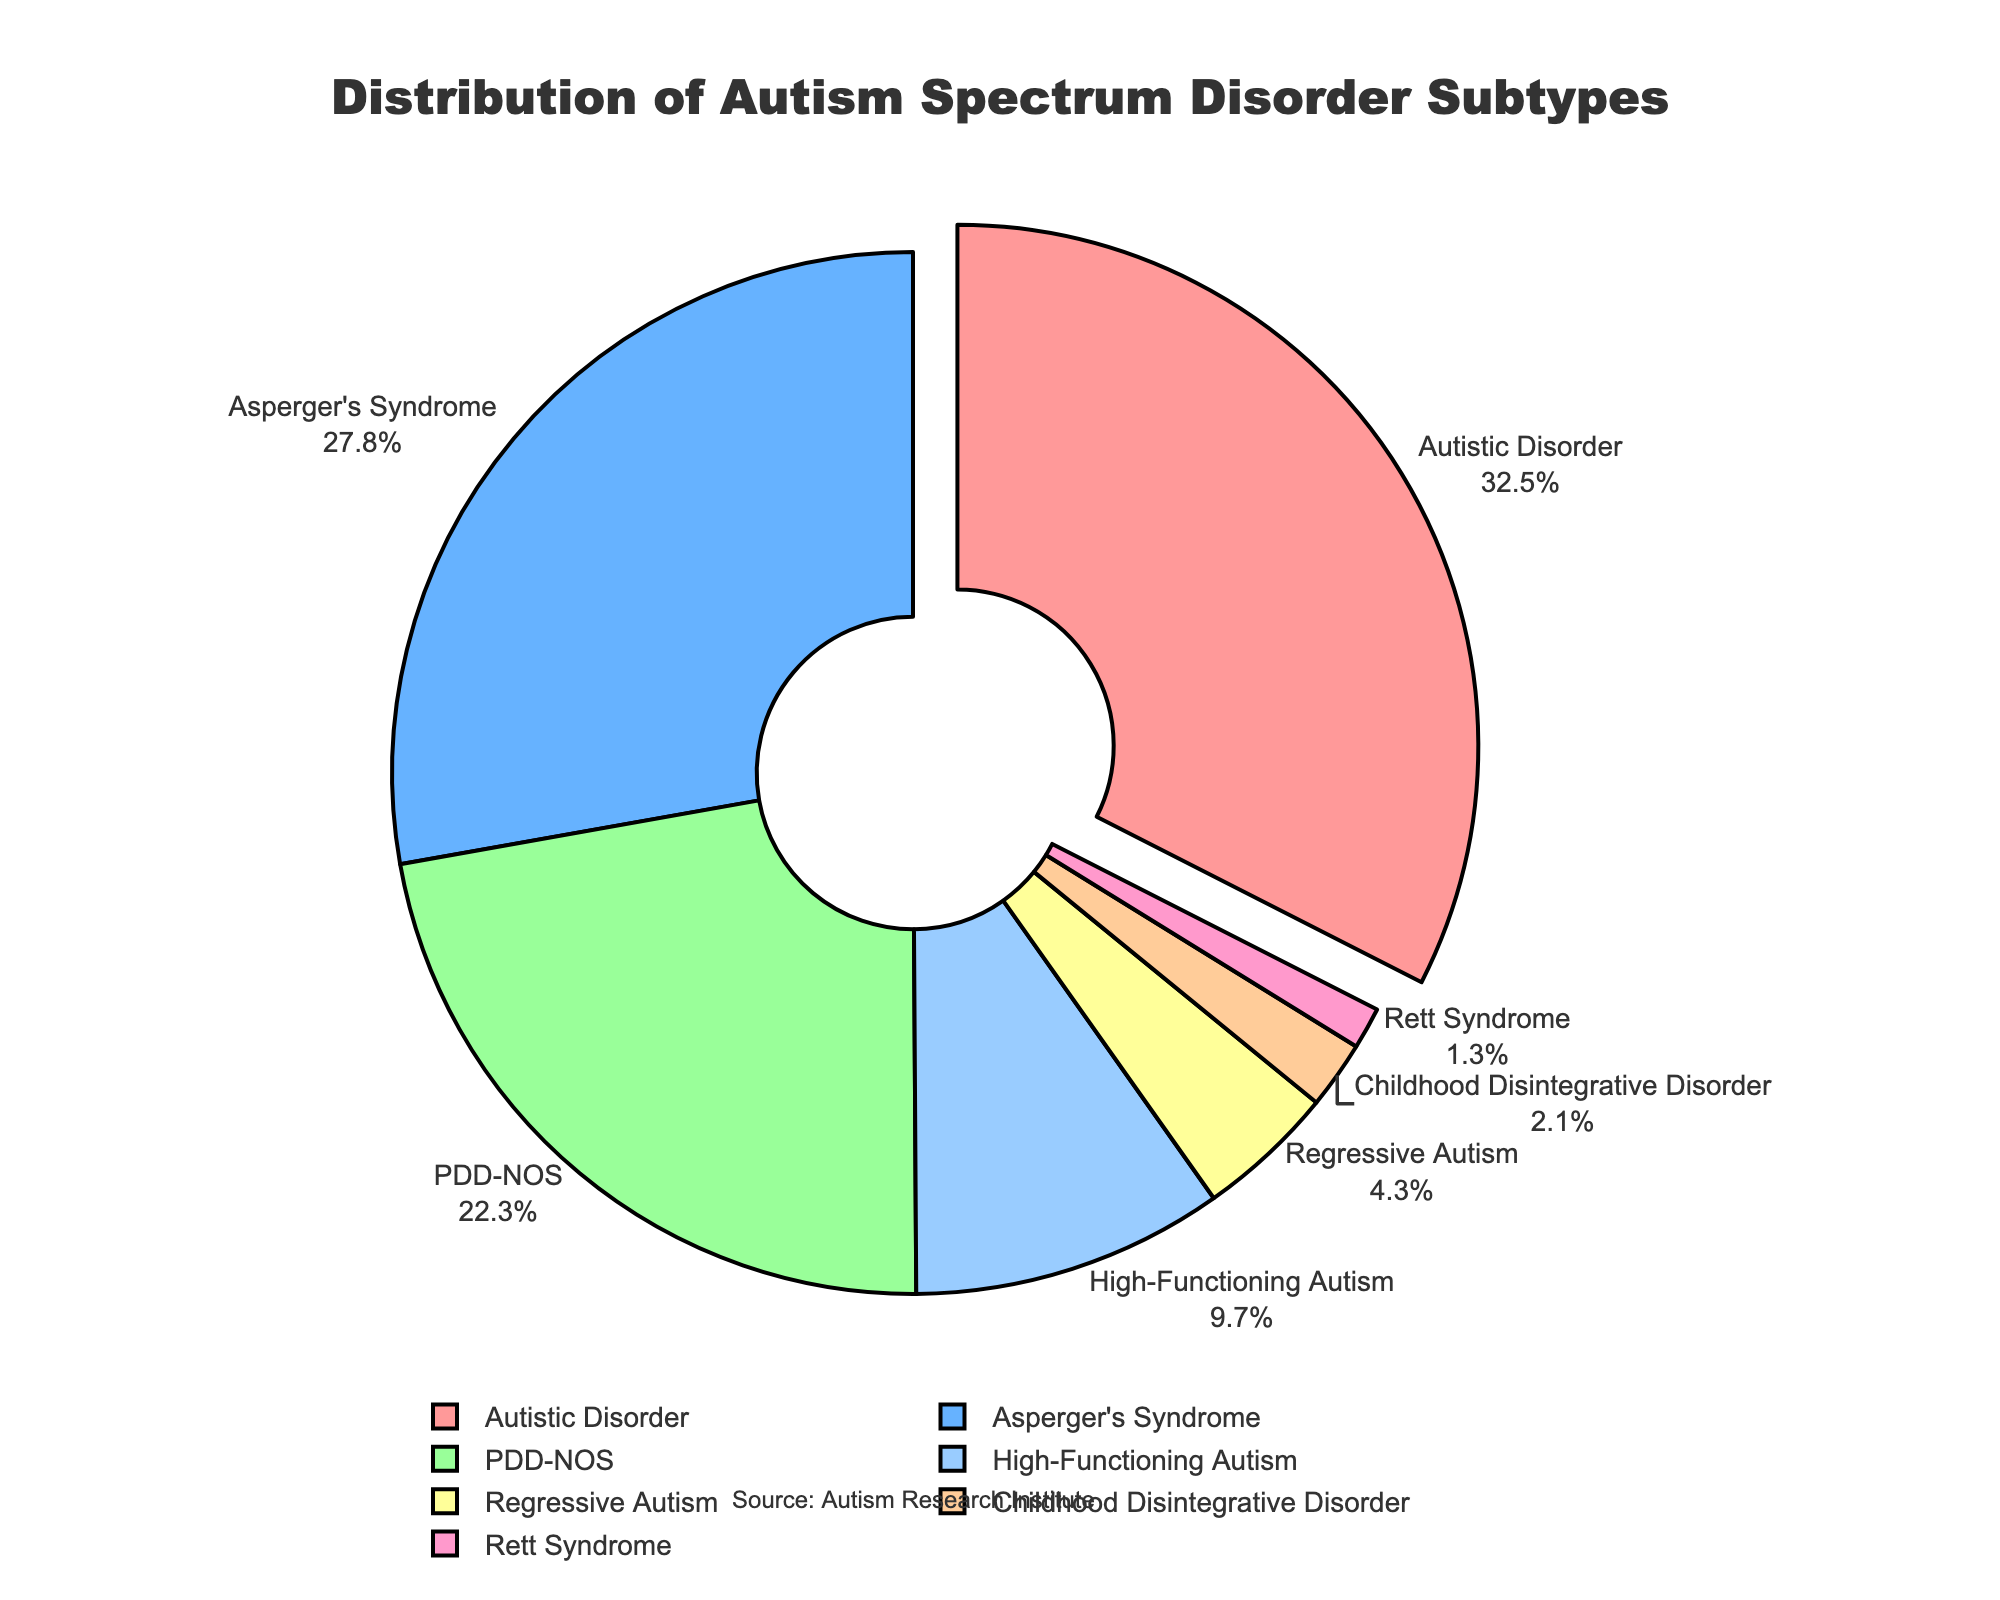What is the subtype with the highest percentage of diagnosed children? The pie chart indicates that the largest portion of the pie represents "Autistic Disorder" with 32.5%.
Answer: Autistic Disorder Which subtype has the smallest percentage among diagnosed children? The smallest section in the pie chart corresponds to "Rett Syndrome" with 1.3%.
Answer: Rett Syndrome What is the combined percentage of children diagnosed with Asperger's Syndrome and High-Functioning Autism? Add the percentages of Asperger's Syndrome (27.8%) and High-Functioning Autism (9.7%): 27.8% + 9.7% = 37.5%.
Answer: 37.5% How does the percentage of children with PDD-NOS compare to those with Regressive Autism? PDD-NOS accounts for 22.3% and Regressive Autism accounts for 4.3%. Thus, PDD-NOS is greater than Regressive Autism by 18%.
Answer: PDD-NOS is greater Which subtype is represented by the red color in the pie chart? The subtype associated with the red color in the pie chart is "Autistic Disorder".
Answer: Autistic Disorder What is the total percentage of children diagnosed with subtypes that have less than a 5% share each? Add the percentages of Childhood Disintegrative Disorder (2.1%), Rett Syndrome (1.3%), and Regressive Autism (4.3%): 2.1% + 1.3% + 4.3% = 7.7%.
Answer: 7.7% Which two subtypes collectively account for more than half of the diagnosed children? By looking at the pie chart, Autistic Disorder (32.5%) and Asperger's Syndrome (27.8%) together exceed 50%: 32.5% + 27.8% = 60.3%.
Answer: Autistic Disorder and Asperger's Syndrome What is the difference in percentage points between High-Functioning Autism and Childhood Disintegrative Disorder? Subtract the percentage of Childhood Disintegrative Disorder (2.1%) from that of High-Functioning Autism (9.7%): 9.7% - 2.1% = 7.6%.
Answer: 7.6% How does the percentage of Rett Syndrome compare to that of PDD-NOS? The percentage of Rett Syndrome (1.3%) is much smaller compared to PDD-NOS (22.3%).
Answer: Rett Syndrome is smaller 